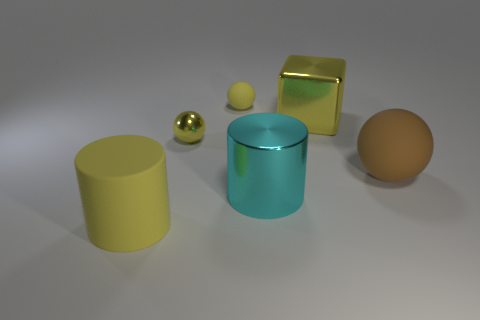Add 2 brown metal cylinders. How many objects exist? 8 Subtract all cubes. How many objects are left? 5 Subtract 1 brown balls. How many objects are left? 5 Subtract all large blocks. Subtract all yellow rubber things. How many objects are left? 3 Add 3 large yellow cylinders. How many large yellow cylinders are left? 4 Add 3 big yellow rubber objects. How many big yellow rubber objects exist? 4 